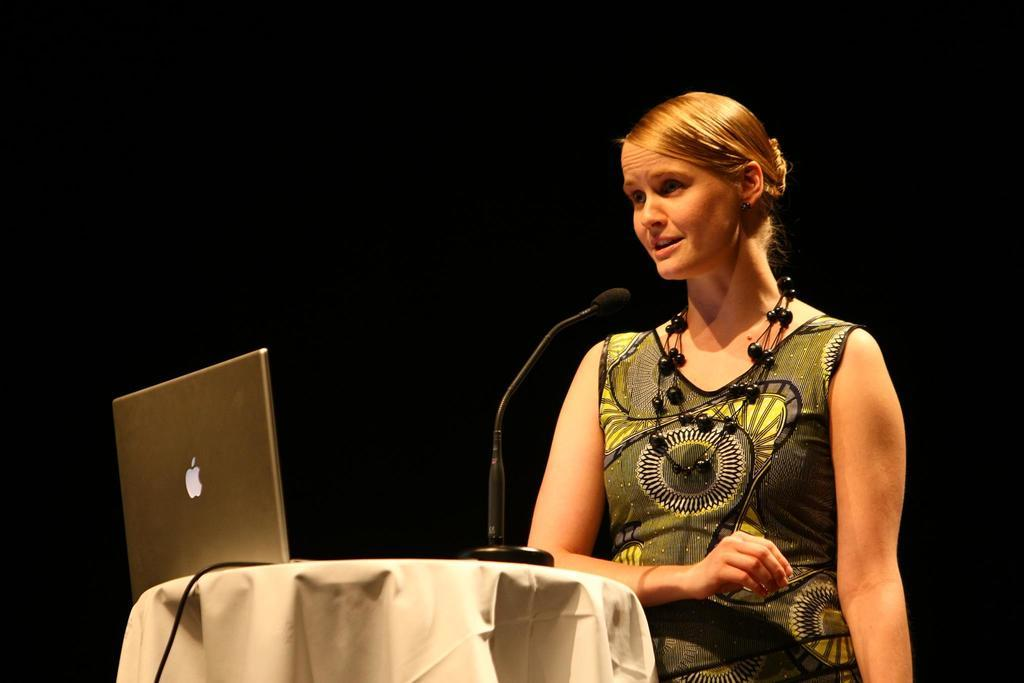Who is present in the image? There is a woman in the image. What is the woman wearing? The woman is wearing a multi-color dress. Where is the woman standing in relation to the table? The woman is standing in front of a table. What items can be seen on the table? There is a laptop and a microphone on the table. How would you describe the background of the image? The background of the image has a dark view. What type of meat is being prepared on the table in the image? There is no meat or any indication of food preparation in the image. 